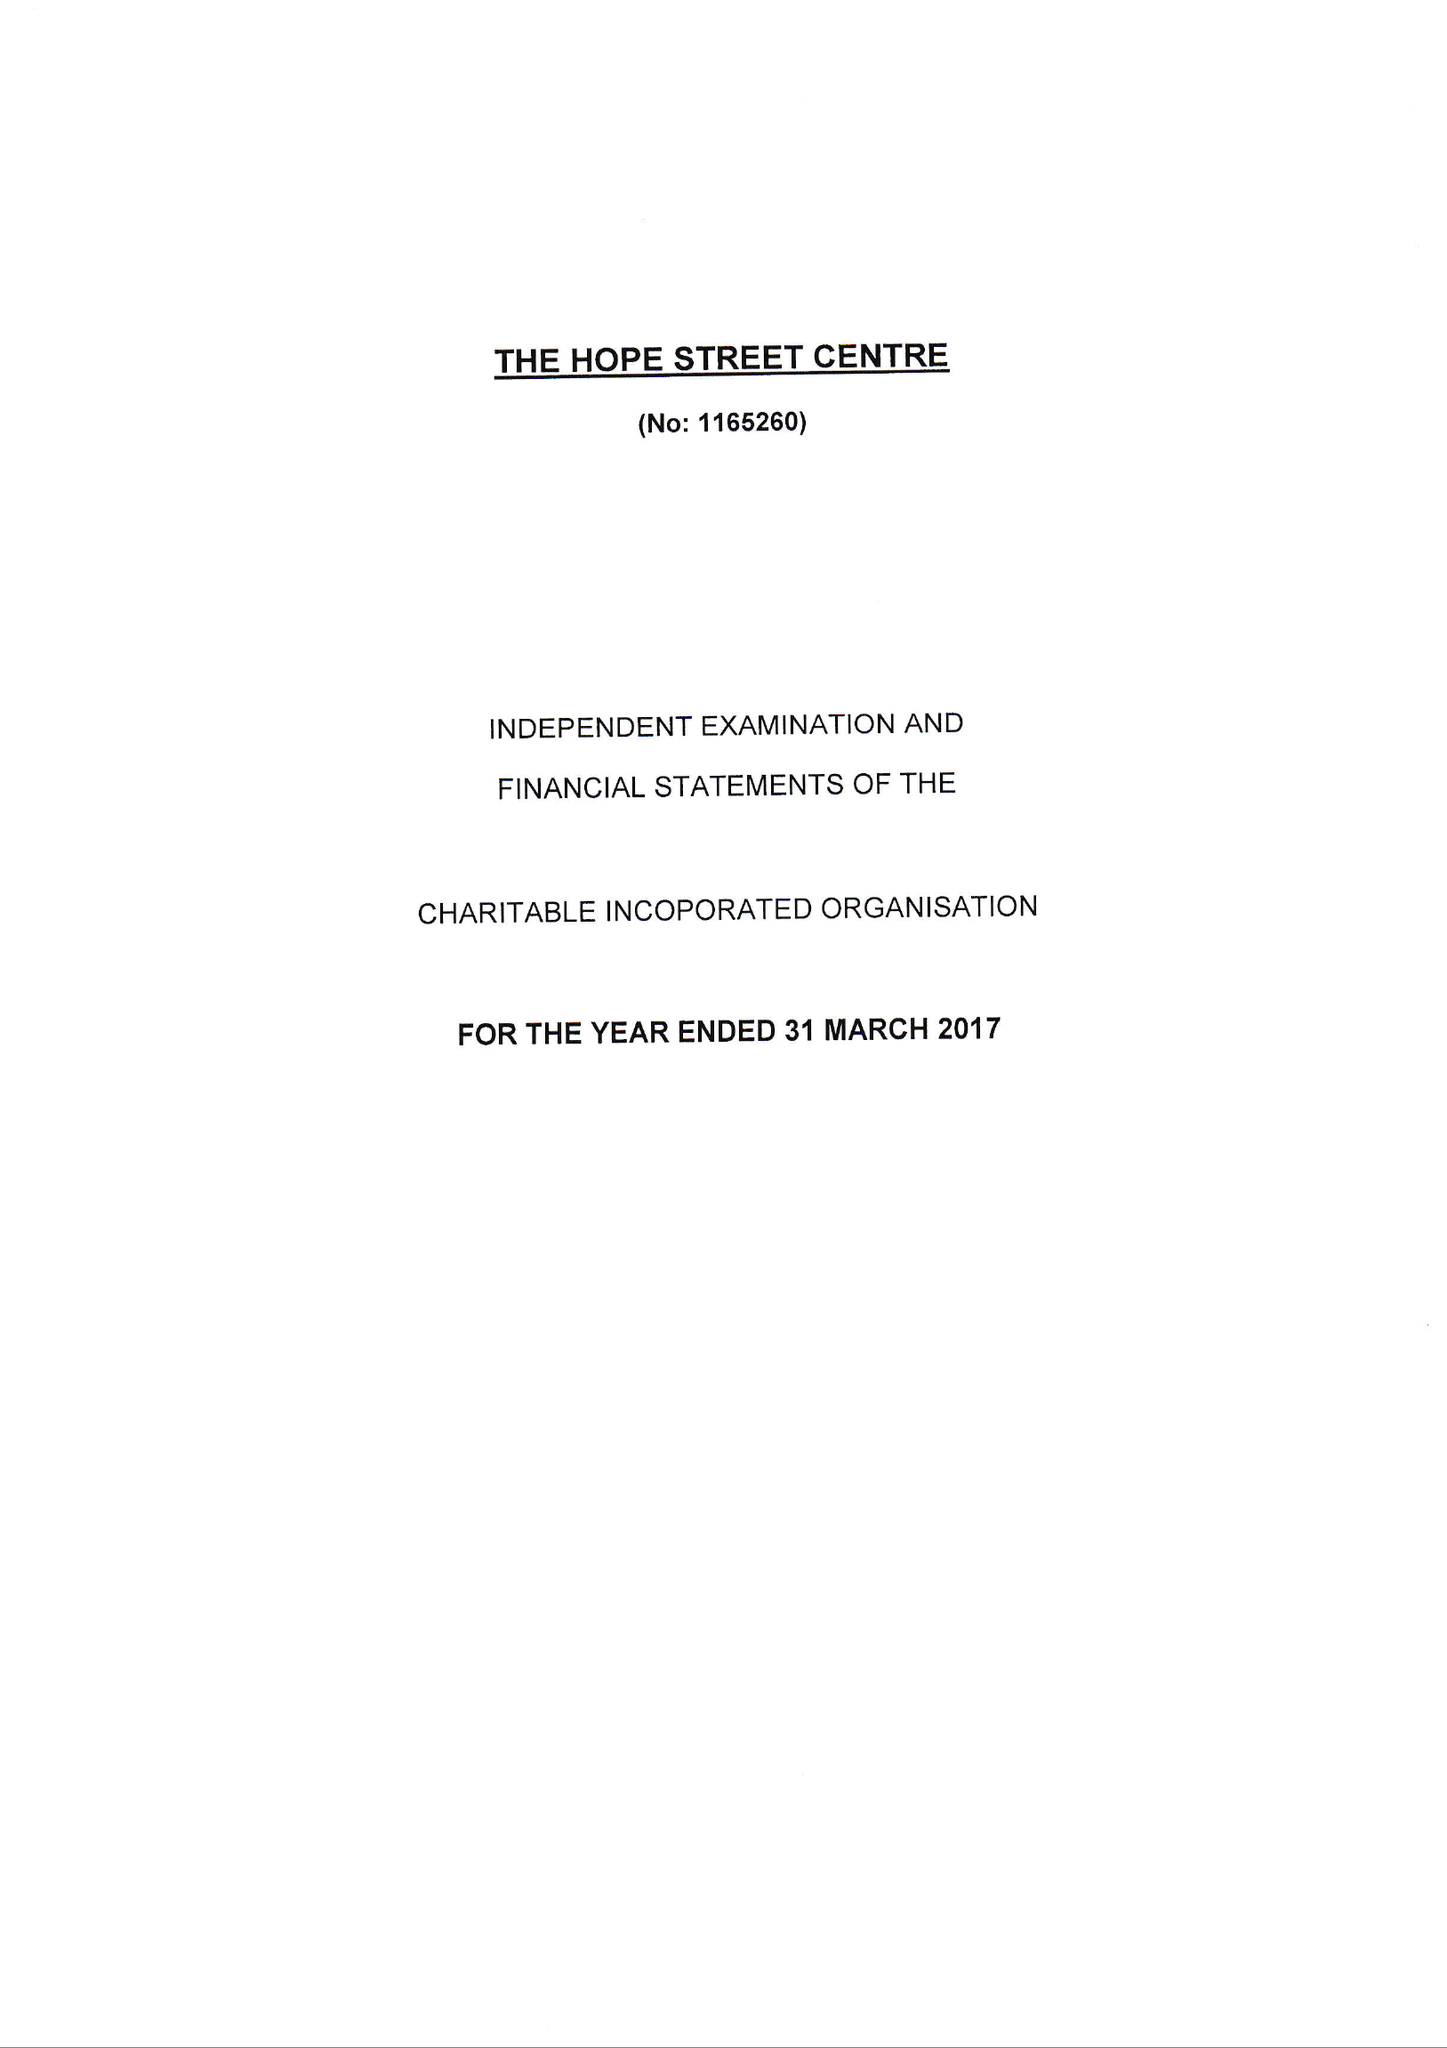What is the value for the address__postcode?
Answer the question using a single word or phrase. ME12 1AJ 